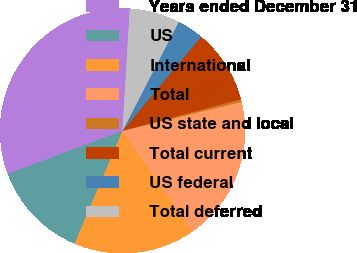<chart> <loc_0><loc_0><loc_500><loc_500><pie_chart><fcel>Years ended December 31<fcel>US<fcel>International<fcel>Total<fcel>US state and local<fcel>Total current<fcel>US federal<fcel>Total deferred<nl><fcel>31.68%<fcel>12.89%<fcel>16.02%<fcel>19.16%<fcel>0.36%<fcel>9.76%<fcel>3.49%<fcel>6.63%<nl></chart> 